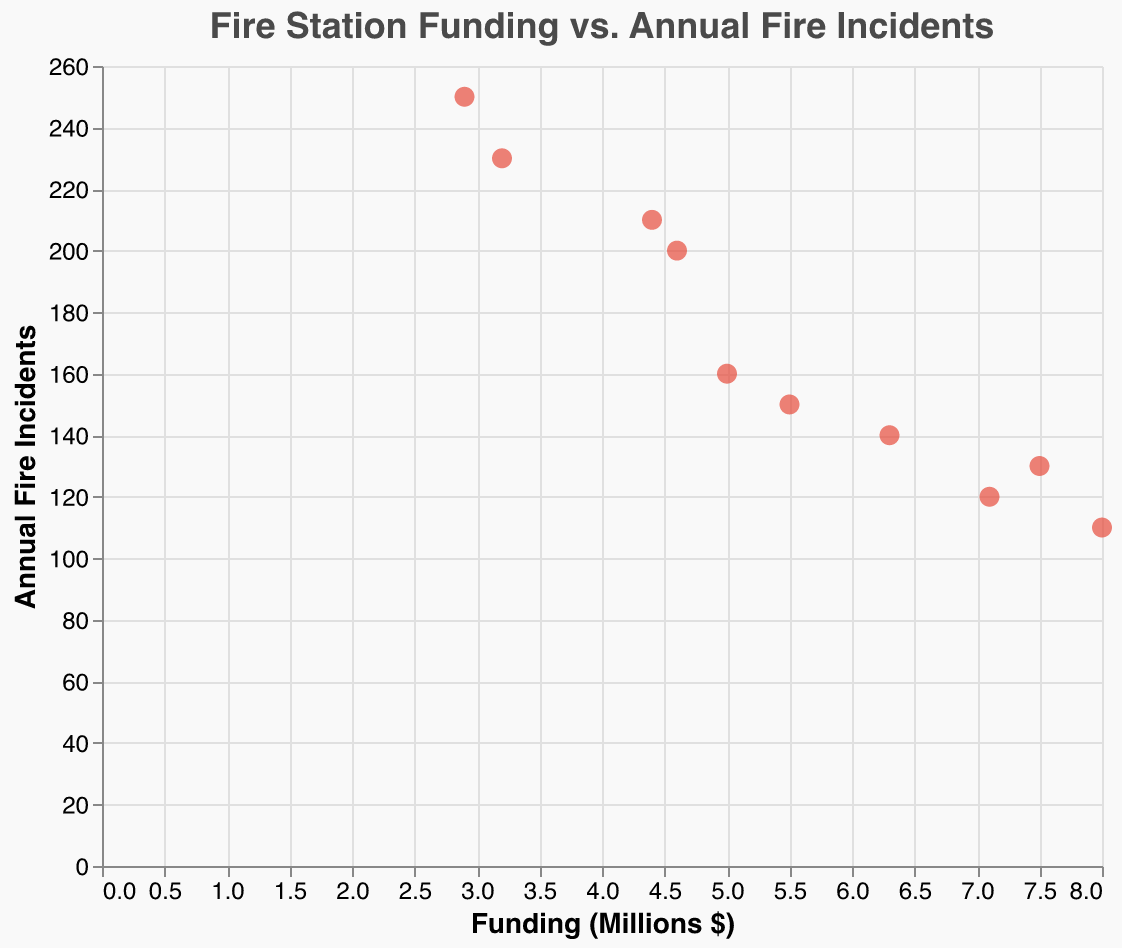How many fire stations are represented in the chart? Count the number of unique data points, which represent the fire stations.
Answer: 10 What is the title of the figure? Look at the top of the figure where the title is displayed.
Answer: Fire Station Funding vs. Annual Fire Incidents Which fire station has the highest number of annual fire incidents? Observe the y-axis value for each data point and find the one with the highest value.
Answer: Station 8 What is the funding amount for the fire station with 210 annual fire incidents? Find the data point where the y-axis value is 210 and check the corresponding x-axis value.
Answer: 4.4 million dollars Which fire station has the lowest funding among all? Check the x-axis values and find the lowest one.
Answer: Station 8 Is there a general trend between funding and the number of annual fire incidents? Look for the overall pattern in the plotted points; observe if the data points show an increasing or decreasing trend.
Answer: No clear trend What is the total funding amount for all fire stations combined? Add up all the x-axis values representing the funding amounts for 10 fire stations: 5.5 + 3.2 + 7.1 + 4.6 + 8.0 + 5.0 + 6.3 + 2.9 + 4.4 + 7.5
Answer: 54.5 million dollars Which fire stations have fewer than 150 annual fire incidents? Identify the data points below 150 on the y-axis.
Answer: Stations 3, 5, 7, 10 Compare the funding between Station 2 and Station 5. Which one has more funding and by how much? Check the x-axis values for both stations: Station 2 (3.2 million) and Station 5 (8.0 million). Subtract the smaller value from the larger one.
Answer: Station 5 by 4.8 million dollars What is the average number of annual fire incidents for all stations? Calculate the sum of y-axis values and divide by the number of stations: (150 + 230 + 120 + 200 + 110 + 160 + 140 + 250 + 210 + 130)/10
Answer: 170 